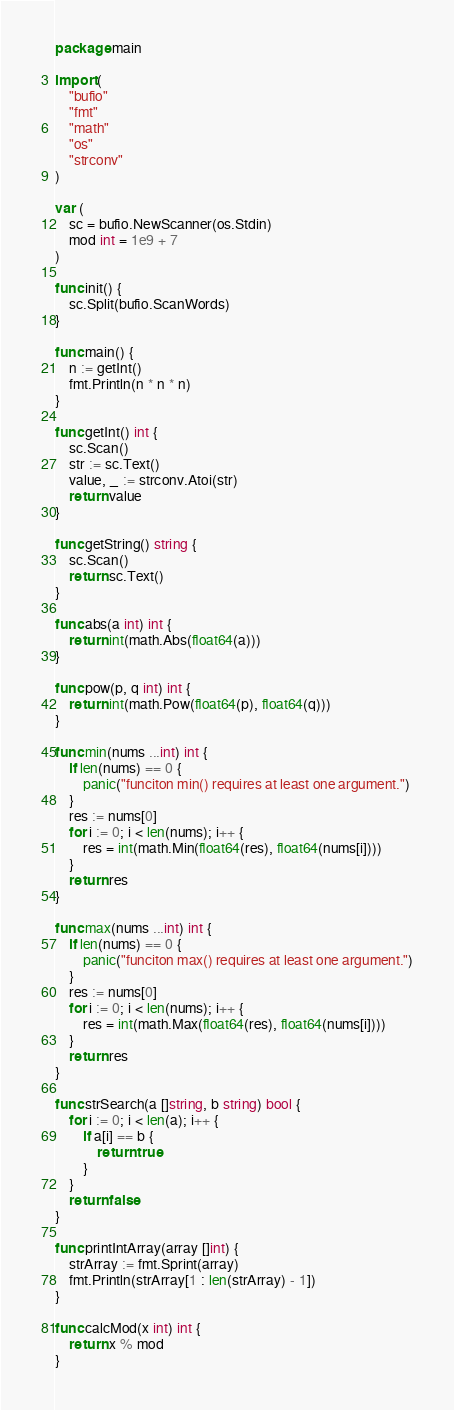Convert code to text. <code><loc_0><loc_0><loc_500><loc_500><_Go_>package main

import (
	"bufio"
	"fmt"
	"math"
	"os"
	"strconv"
)

var (
	sc = bufio.NewScanner(os.Stdin)
	mod int = 1e9 + 7
)

func init() {
	sc.Split(bufio.ScanWords)
}

func main() {
	n := getInt()
	fmt.Println(n * n * n)
}

func getInt() int {
	sc.Scan()
	str := sc.Text()
	value, _ := strconv.Atoi(str)
	return value
}

func getString() string {
	sc.Scan()
	return sc.Text()
}

func abs(a int) int {
	return int(math.Abs(float64(a)))
}

func pow(p, q int) int {
	return int(math.Pow(float64(p), float64(q)))
}

func min(nums ...int) int {
	if len(nums) == 0 {
		panic("funciton min() requires at least one argument.")
	}
	res := nums[0]
	for i := 0; i < len(nums); i++ {
		res = int(math.Min(float64(res), float64(nums[i])))
	}
	return res
}

func max(nums ...int) int {
	if len(nums) == 0 {
		panic("funciton max() requires at least one argument.")
	}
	res := nums[0]
	for i := 0; i < len(nums); i++ {
		res = int(math.Max(float64(res), float64(nums[i])))
	}
	return res
}

func strSearch(a []string, b string) bool {
	for i := 0; i < len(a); i++ {
		if a[i] == b {
			return true
		}
	}
	return false
}

func printIntArray(array []int) {
	strArray := fmt.Sprint(array)
	fmt.Println(strArray[1 : len(strArray) - 1])
}

func calcMod(x int) int {
	return x % mod
}
</code> 